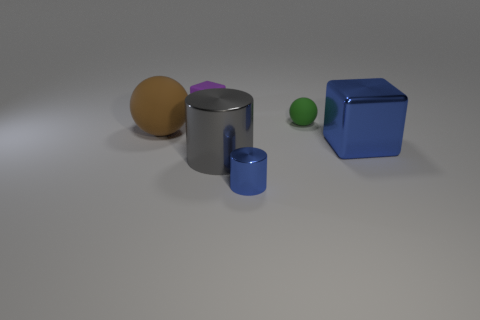Add 2 rubber blocks. How many objects exist? 8 Subtract all gray blocks. Subtract all blue spheres. How many blocks are left? 2 Subtract all gray spheres. How many blue cylinders are left? 1 Subtract all blocks. Subtract all brown balls. How many objects are left? 3 Add 2 large gray metal cylinders. How many large gray metal cylinders are left? 3 Add 5 big brown objects. How many big brown objects exist? 6 Subtract 0 purple spheres. How many objects are left? 6 Subtract all spheres. How many objects are left? 4 Subtract 2 blocks. How many blocks are left? 0 